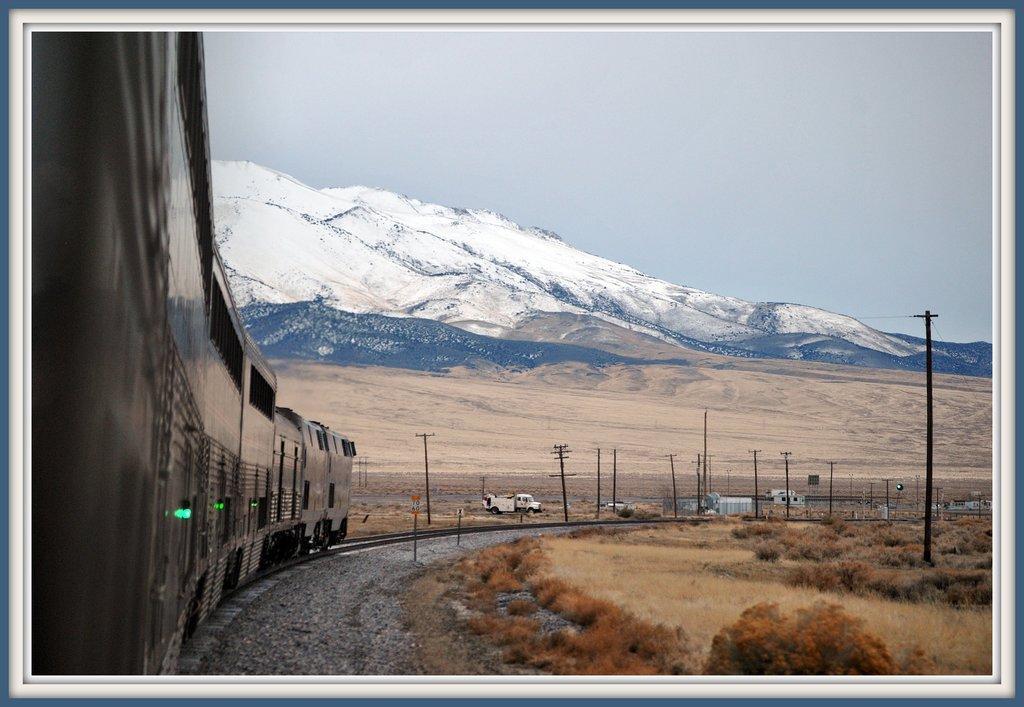Describe this image in one or two sentences. In this image, we can see a train on the track. At the bottom, we can see walkway, plants, stones. Background we can see poles, vehicles, houses, hills and sky. We can see white color and blue color borders on this image. 